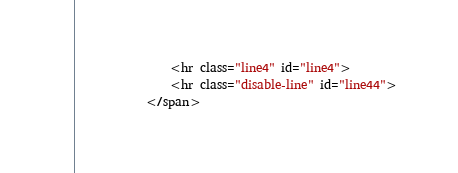<code> <loc_0><loc_0><loc_500><loc_500><_HTML_>                <hr class="line4" id="line4">
                <hr class="disable-line" id="line44">
            </span></code> 